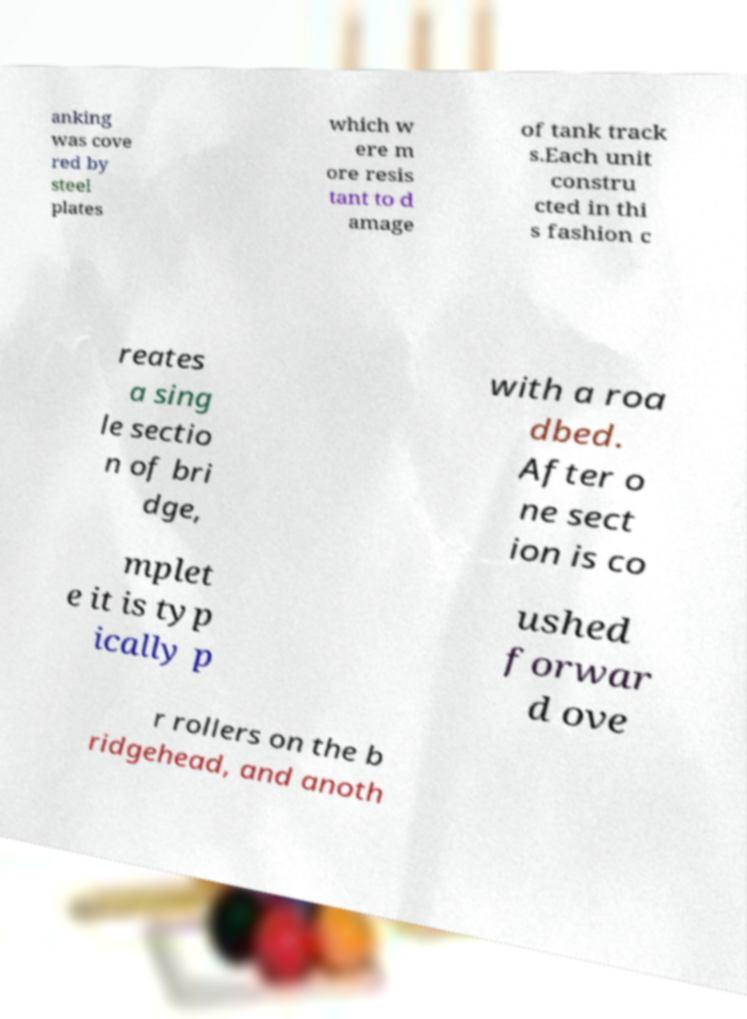Could you assist in decoding the text presented in this image and type it out clearly? anking was cove red by steel plates which w ere m ore resis tant to d amage of tank track s.Each unit constru cted in thi s fashion c reates a sing le sectio n of bri dge, with a roa dbed. After o ne sect ion is co mplet e it is typ ically p ushed forwar d ove r rollers on the b ridgehead, and anoth 